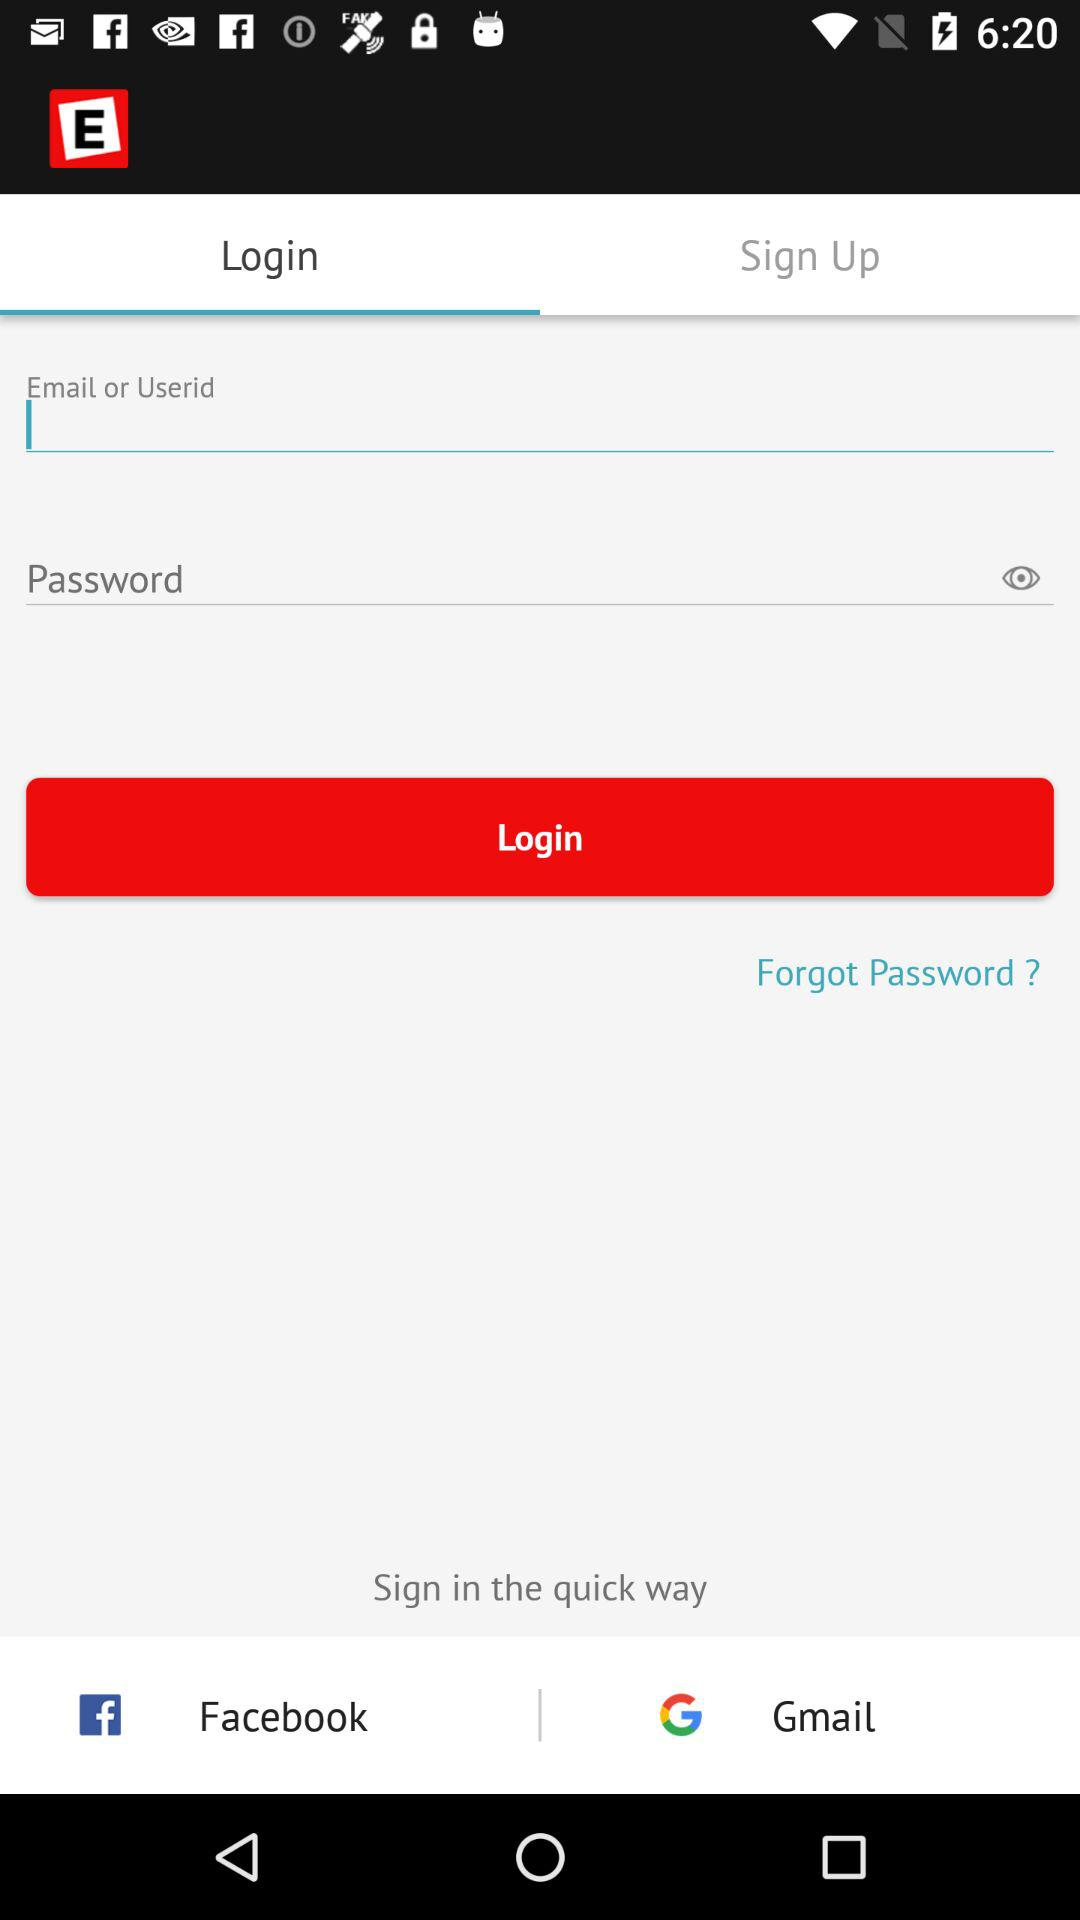What accounts can I use to sign in? You can use "Facebook" and "Gmail" to sign in. 